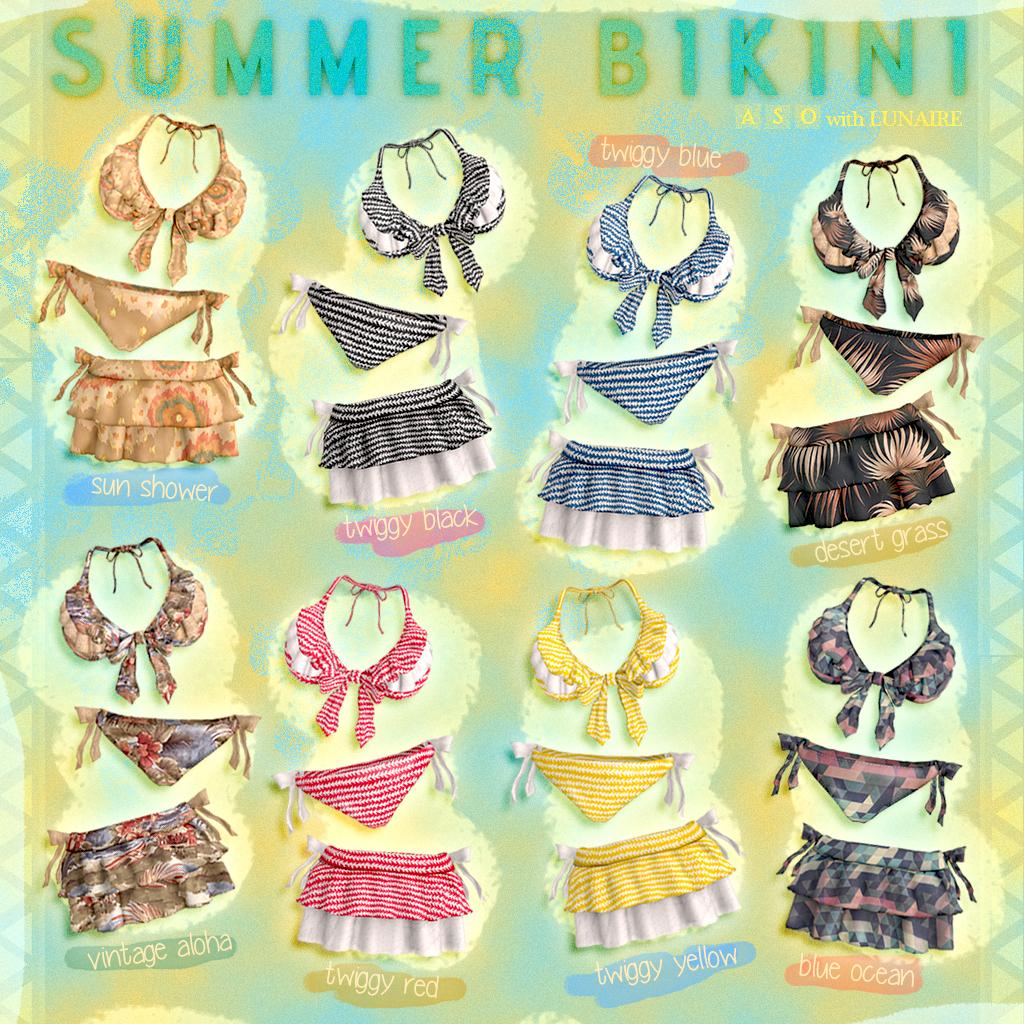What type of clothing items are visible in the image? There are bras, panties, and skirts in the image. What is the text above the bras, panties, and skirts? The image contains a text above these clothing items, but the specific text is not mentioned in the provided facts. What can be inferred about the nature of the image? The image is graphic in nature. Where is the badge located on the bras in the image? There is no badge present on the bras in the image. What type of account is associated with the clothing items in the image? The provided facts do not mention any accounts related to the clothing items in the image. 